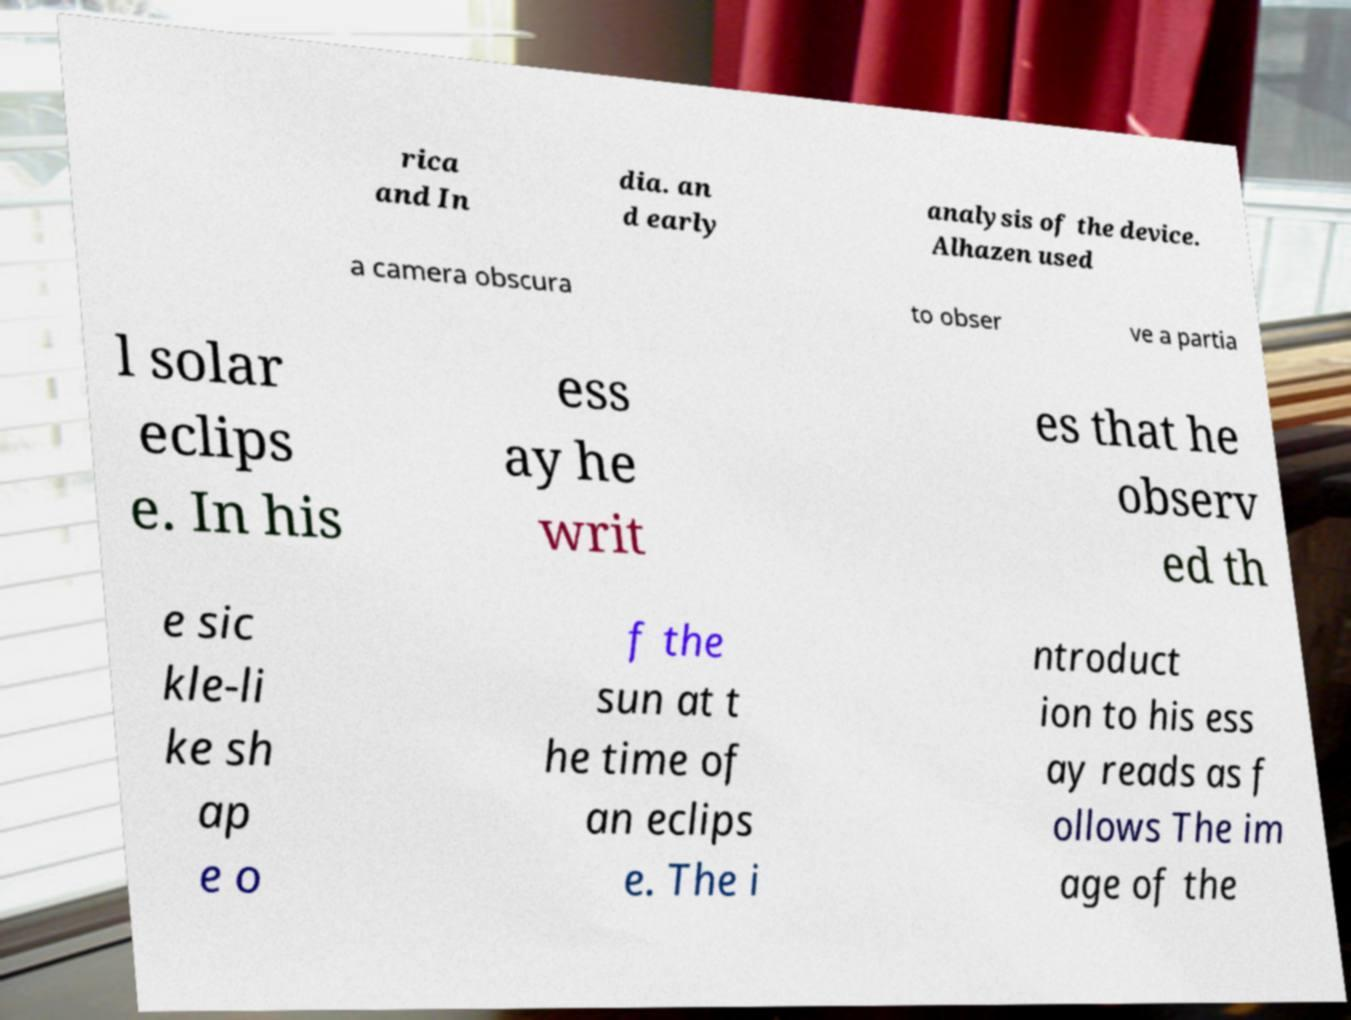Can you accurately transcribe the text from the provided image for me? rica and In dia. an d early analysis of the device. Alhazen used a camera obscura to obser ve a partia l solar eclips e. In his ess ay he writ es that he observ ed th e sic kle-li ke sh ap e o f the sun at t he time of an eclips e. The i ntroduct ion to his ess ay reads as f ollows The im age of the 